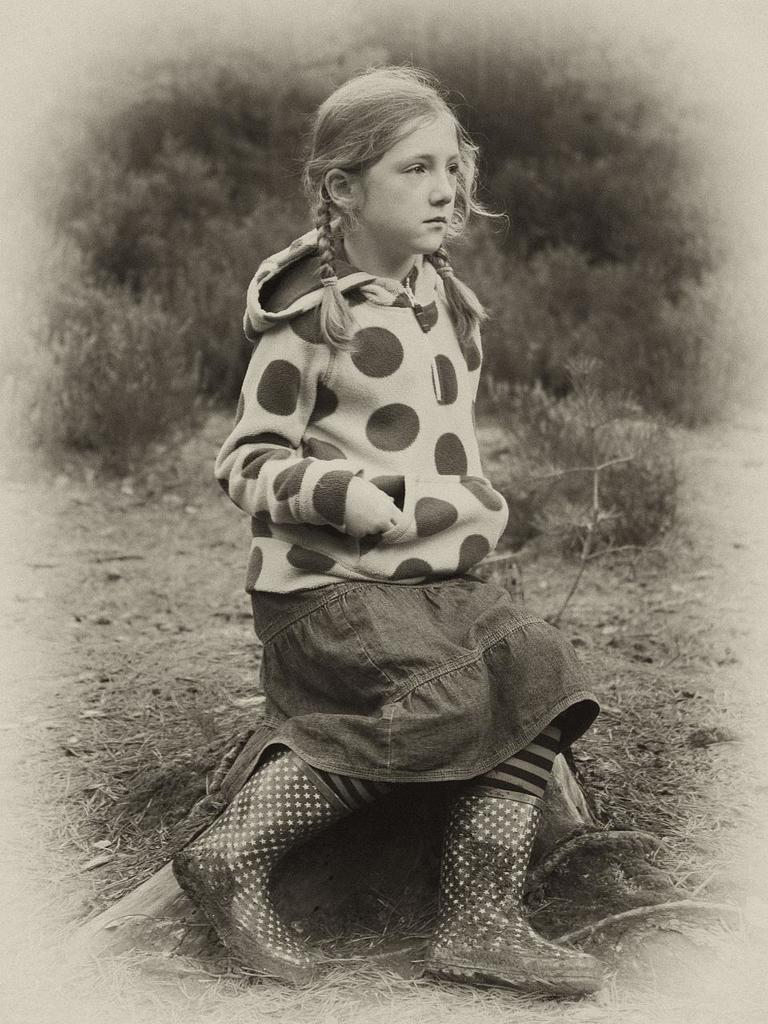What is the color scheme of the photograph? The photograph is black and white. Who is the main subject in the photograph? There is a girl in the photograph. What is the girl doing in the photograph? The girl is sitting on a stone. What can be seen in the background of the photograph? There are plants visible behind the girl. What is the purpose of the lace in the photograph? There is no lace present in the photograph. How is the girl related to the person taking the photograph? The facts provided do not give any information about the relationship between the girl and the person taking the photograph. 